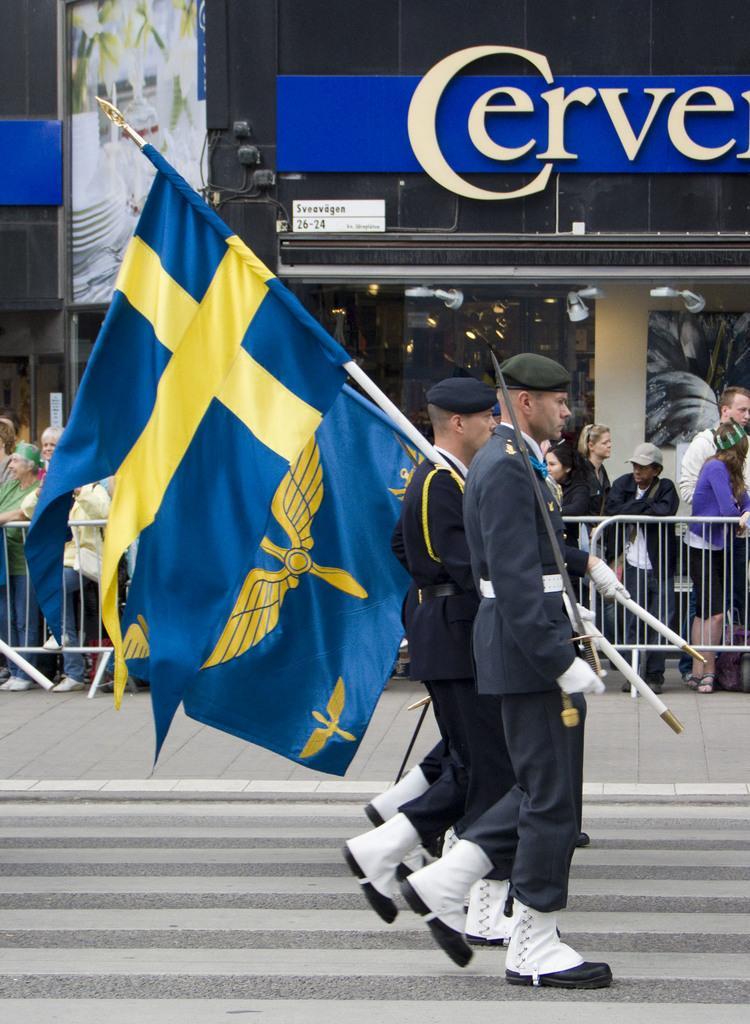Can you describe this image briefly? This picture is clicked outside. On the right we can see the group of persons wearing uniforms, holding flags and walking on the zebra crossing. In the background we can see the group of people standing on the ground and we can see the buildings and text on the building and metal rods. 